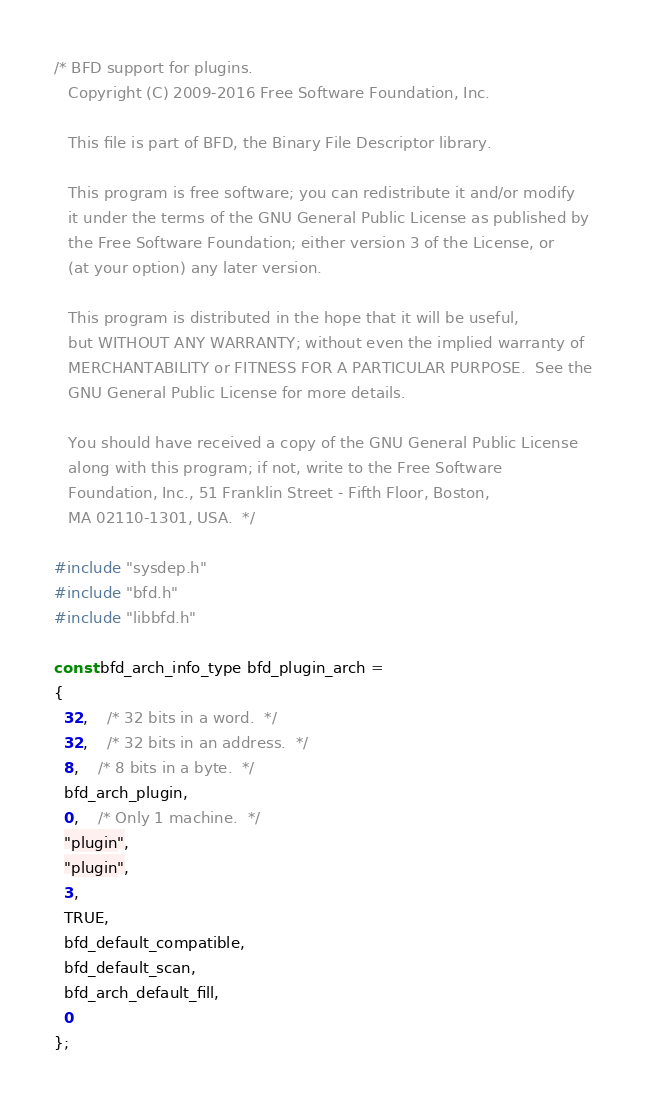Convert code to text. <code><loc_0><loc_0><loc_500><loc_500><_C_>/* BFD support for plugins.
   Copyright (C) 2009-2016 Free Software Foundation, Inc.

   This file is part of BFD, the Binary File Descriptor library.

   This program is free software; you can redistribute it and/or modify
   it under the terms of the GNU General Public License as published by
   the Free Software Foundation; either version 3 of the License, or
   (at your option) any later version.

   This program is distributed in the hope that it will be useful,
   but WITHOUT ANY WARRANTY; without even the implied warranty of
   MERCHANTABILITY or FITNESS FOR A PARTICULAR PURPOSE.  See the
   GNU General Public License for more details.

   You should have received a copy of the GNU General Public License
   along with this program; if not, write to the Free Software
   Foundation, Inc., 51 Franklin Street - Fifth Floor, Boston,
   MA 02110-1301, USA.  */

#include "sysdep.h"
#include "bfd.h"
#include "libbfd.h"

const bfd_arch_info_type bfd_plugin_arch =
{
  32,	/* 32 bits in a word.  */
  32,	/* 32 bits in an address.  */
  8,	/* 8 bits in a byte.  */
  bfd_arch_plugin,
  0,	/* Only 1 machine.  */
  "plugin",
  "plugin",
  3,
  TRUE,
  bfd_default_compatible,
  bfd_default_scan,
  bfd_arch_default_fill,
  0
};
</code> 